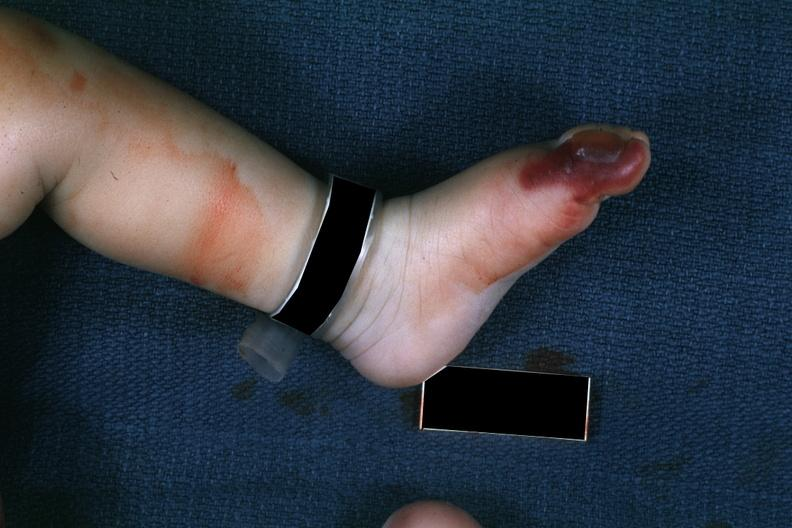re skin over back a buttocks present?
Answer the question using a single word or phrase. No 